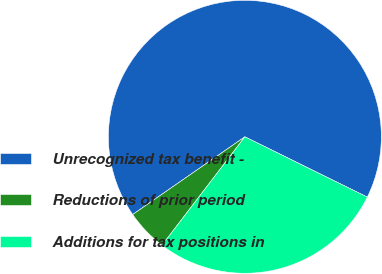<chart> <loc_0><loc_0><loc_500><loc_500><pie_chart><fcel>Unrecognized tax benefit -<fcel>Reductions of prior period<fcel>Additions for tax positions in<nl><fcel>66.93%<fcel>4.97%<fcel>28.1%<nl></chart> 